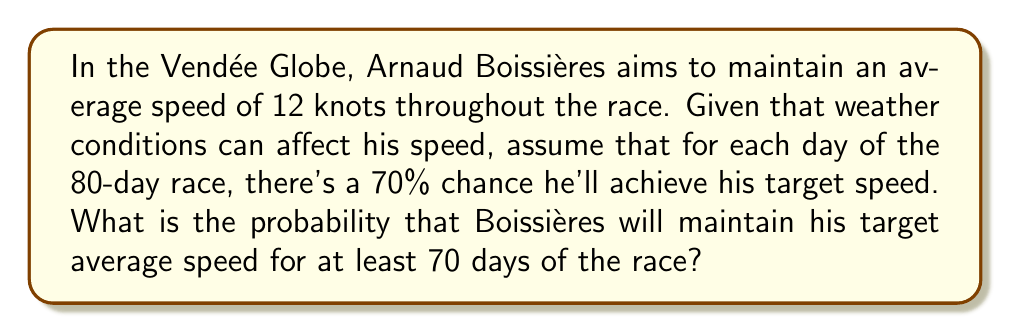Give your solution to this math problem. Let's approach this step-by-step:

1) This scenario follows a binomial distribution, where:
   $n = 80$ (total number of days)
   $p = 0.70$ (probability of success each day)
   $k \geq 70$ (we want at least 70 successful days)

2) The probability of maintaining the target speed for at least 70 days is the sum of probabilities for 70, 71, 72, ..., up to 80 days.

3) We can use the cumulative binomial probability formula:

   $$P(X \geq 70) = \sum_{k=70}^{80} \binom{80}{k} p^k (1-p)^{80-k}$$

4) This can be rewritten as:

   $$P(X \geq 70) = 1 - P(X < 70) = 1 - P(X \leq 69)$$

5) Using a calculator or computer (as manual calculation would be tedious), we find:

   $$P(X \geq 70) = 1 - 0.0182 = 0.9818$$

6) Therefore, the probability is approximately 0.9818 or 98.18%.
Answer: $0.9818$ or $98.18\%$ 